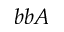Convert formula to latex. <formula><loc_0><loc_0><loc_500><loc_500>b b A</formula> 